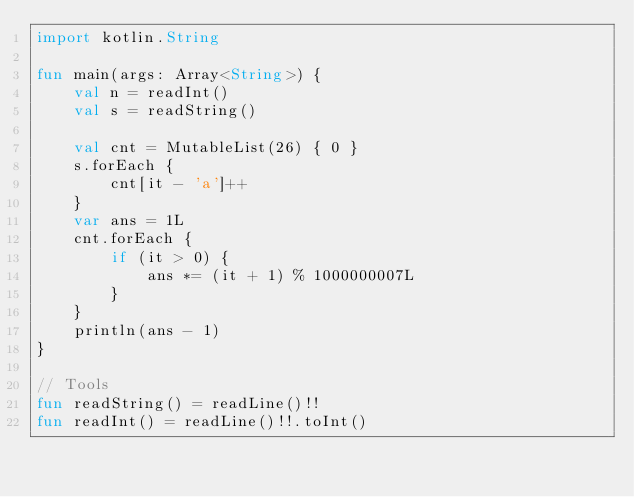<code> <loc_0><loc_0><loc_500><loc_500><_Kotlin_>import kotlin.String

fun main(args: Array<String>) {
    val n = readInt()
    val s = readString()

    val cnt = MutableList(26) { 0 }
    s.forEach {
        cnt[it - 'a']++
    }
    var ans = 1L
    cnt.forEach {
        if (it > 0) {
            ans *= (it + 1) % 1000000007L
        }
    }
    println(ans - 1)
}

// Tools
fun readString() = readLine()!!
fun readInt() = readLine()!!.toInt()</code> 